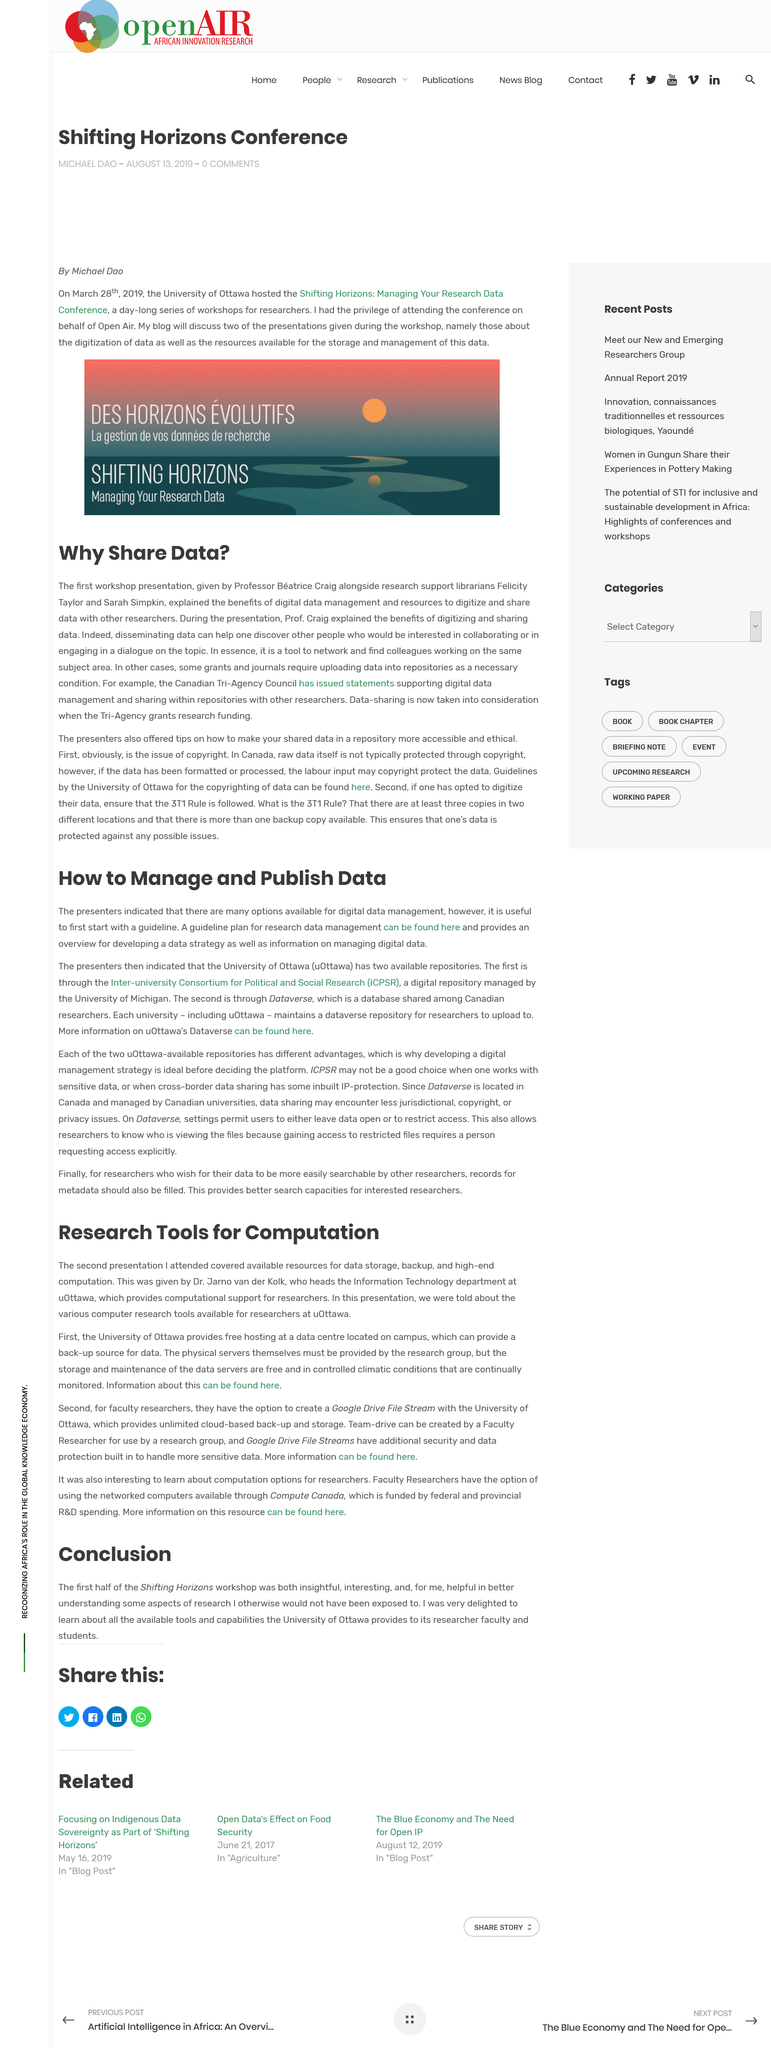Point out several critical features in this image. The author of the article attended the conference on behalf of Open Air. Professor Beatrice Craig explained in the first presentation the importance of sharing data and the benefits of digitizing it, which included improving accessibility and collaboration. It is useful for presenters to first start with a guideline when it comes to what they are discussing. Michael Dao attended the conference on behalf of Open Air. The article uses the word "data" five times in total. 